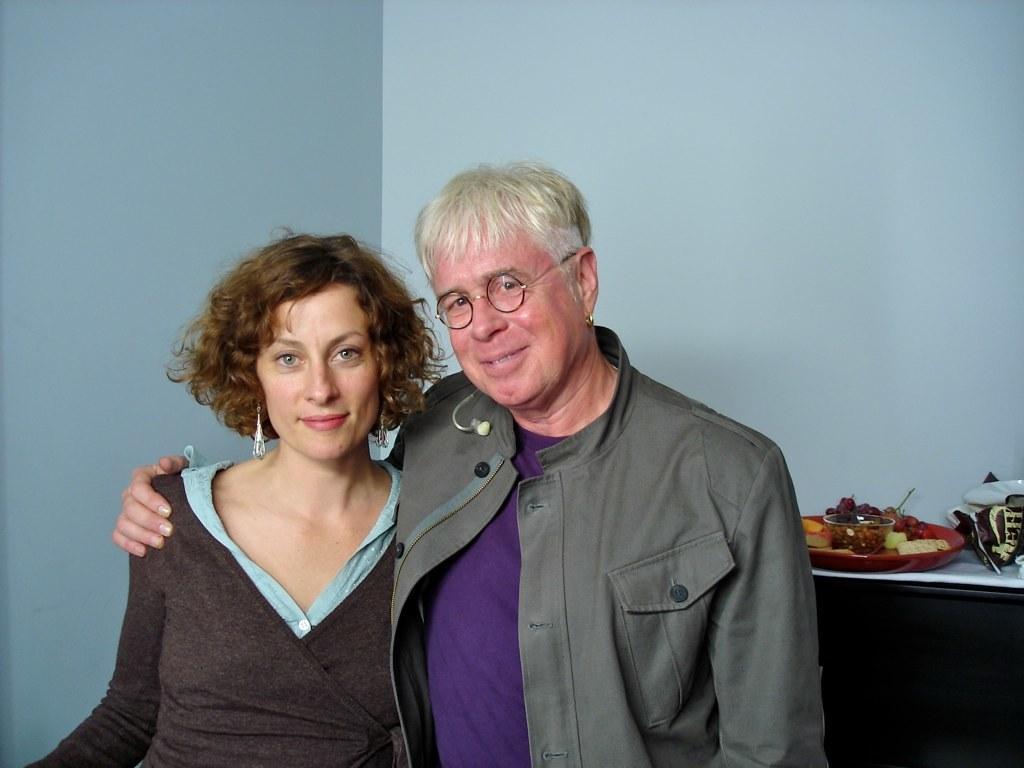How would you summarize this image in a sentence or two? In this picture I can see there is a man and a woman standing and the man is wearing a coat and is having spectacles, the woman is wearing a shirt. They are smiling and in the backdrop there is a wooden table and there is a plate of food placed on it. There is a wall in the backdrop. 